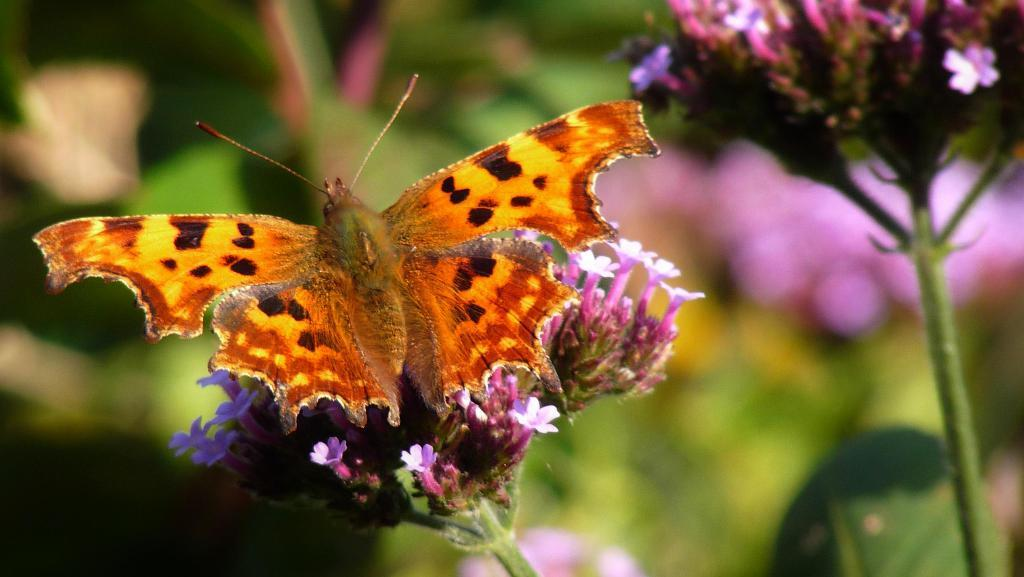What is the main subject of the image? The main subject of the image is the plants. What specific feature do the plants have? The plants have flowers. Is there any other living creature visible in the image? Yes, there is a butterfly on one of the plants. How would you describe the background of the image? The background of the image is blurred. What type of nose can be seen on the butterfly in the image? Butterflies do not have noses, so there is no nose visible on the butterfly in the image. 